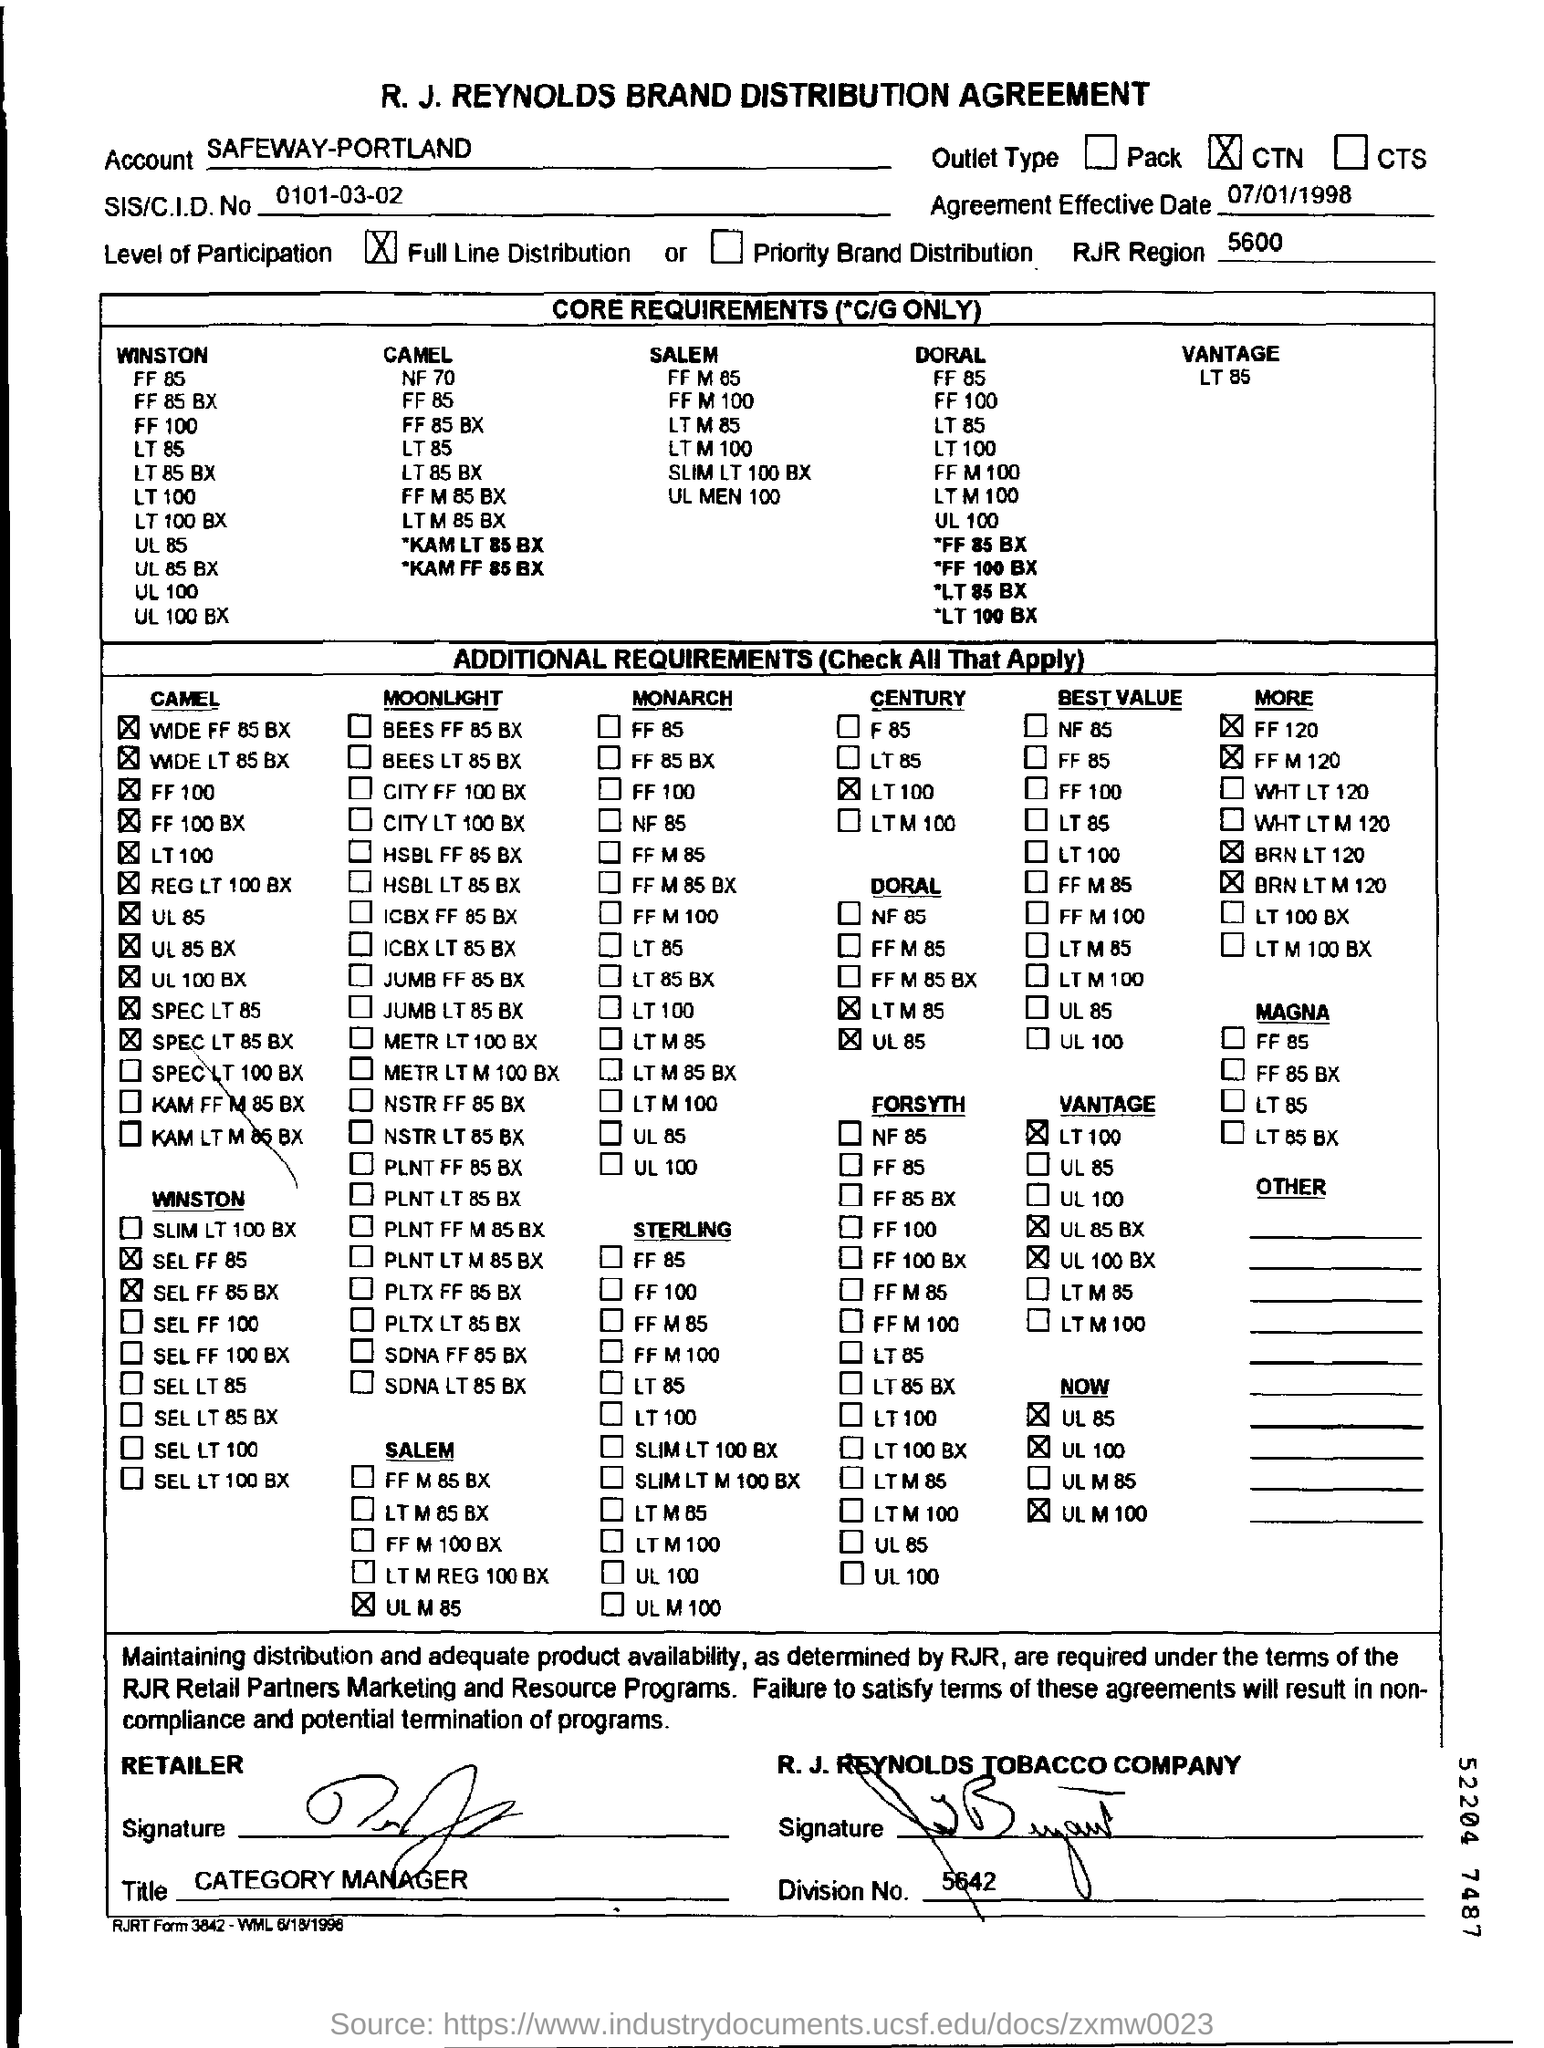What is name of the company written on the top of the document?
Make the answer very short. R.J. REYNOLDS BRAND DISTRIBUTION AGREEMENT. What is SIS/CID no?
Your answer should be compact. 0101-03-02. What is agreement effective date?
Your answer should be compact. 07/01/1998. What is the level of participation as per the document?
Offer a terse response. Full Line Distribution. What is RJR Region
Offer a terse response. 5600. What is division number as per the document
Provide a short and direct response. 5642. 